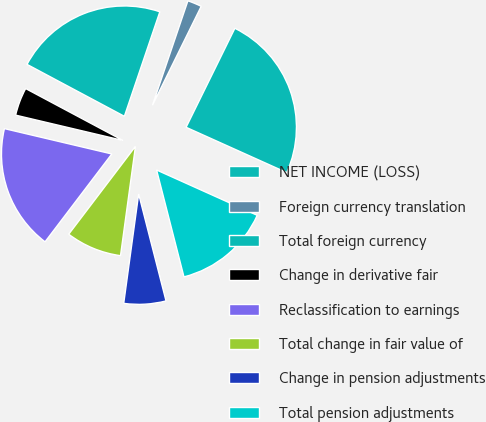<chart> <loc_0><loc_0><loc_500><loc_500><pie_chart><fcel>NET INCOME (LOSS)<fcel>Foreign currency translation<fcel>Total foreign currency<fcel>Change in derivative fair<fcel>Reclassification to earnings<fcel>Total change in fair value of<fcel>Change in pension adjustments<fcel>Total pension adjustments<nl><fcel>24.45%<fcel>2.08%<fcel>22.41%<fcel>4.11%<fcel>18.35%<fcel>8.18%<fcel>6.15%<fcel>14.28%<nl></chart> 